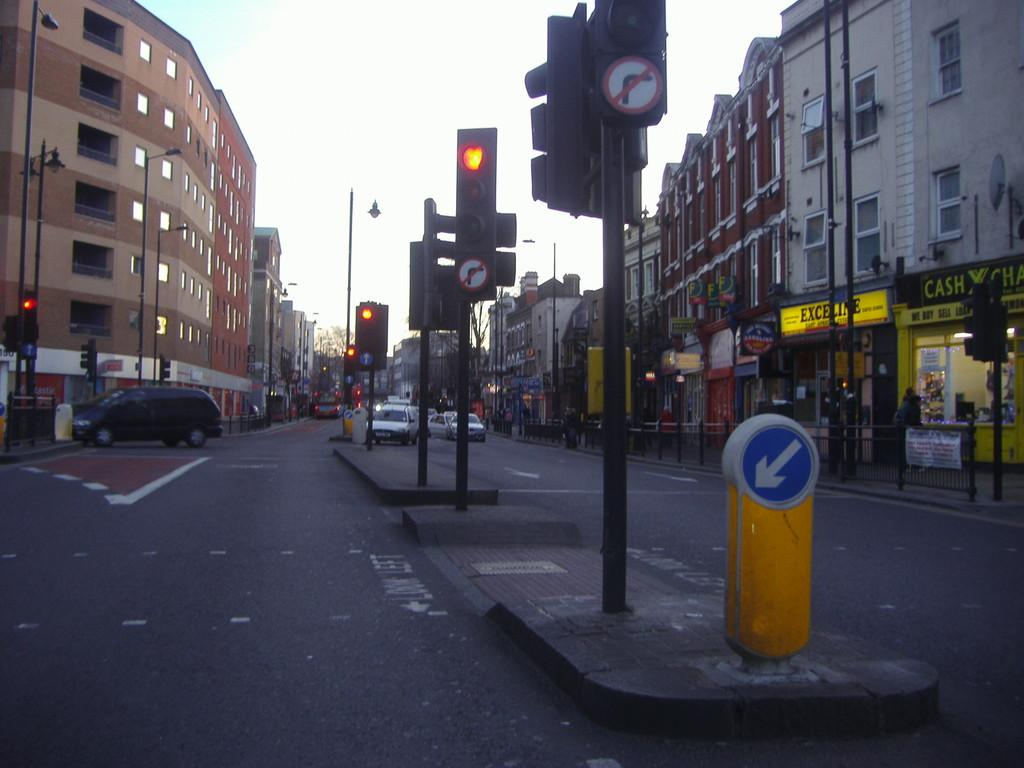<image>
Relay a brief, clear account of the picture shown. Several street lights are secured in the center of medians that separate traffic, in a bust city area, near a Cash exchange. 